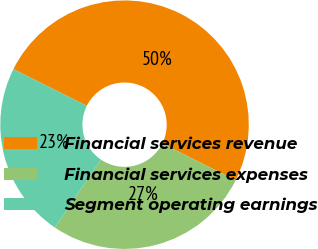<chart> <loc_0><loc_0><loc_500><loc_500><pie_chart><fcel>Financial services revenue<fcel>Financial services expenses<fcel>Segment operating earnings<nl><fcel>50.0%<fcel>27.09%<fcel>22.91%<nl></chart> 